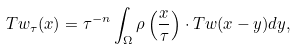<formula> <loc_0><loc_0><loc_500><loc_500>T w _ { \tau } ( x ) = \tau ^ { - n } \int _ { \Omega } \rho \left ( \frac { x } { \tau } \right ) \cdot T w ( x - y ) d y ,</formula> 